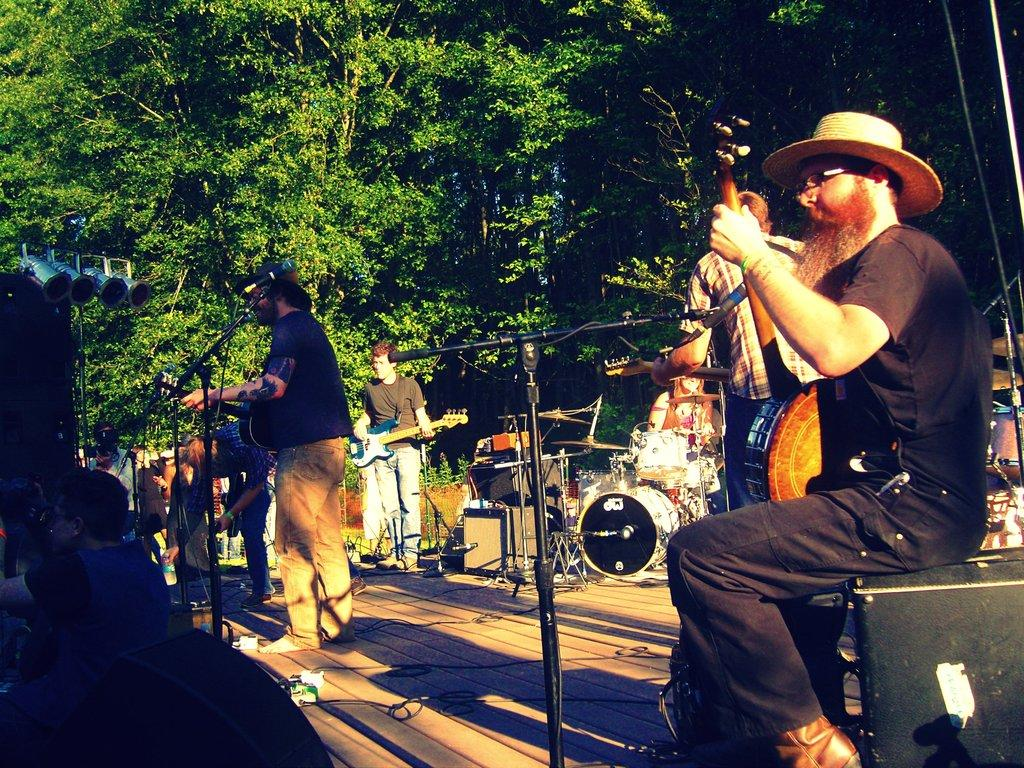What type of natural elements can be seen in the image? There are trees in the image. What else is present in the image besides the trees? There are people in the image. What are the people doing in the image? The people are playing musical instruments. What type of toy can be seen bouncing on the spring in the image? There is no toy or spring present in the image; it features trees and people playing musical instruments. 